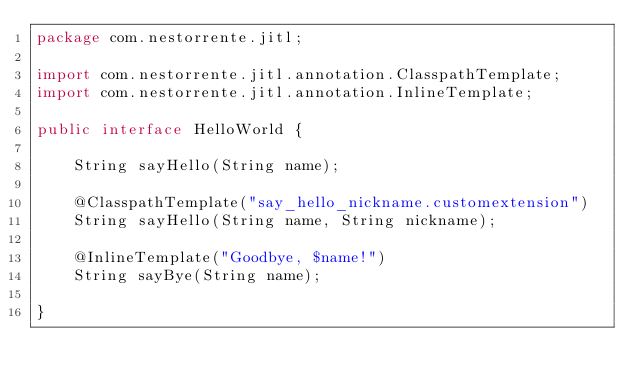Convert code to text. <code><loc_0><loc_0><loc_500><loc_500><_Java_>package com.nestorrente.jitl;

import com.nestorrente.jitl.annotation.ClasspathTemplate;
import com.nestorrente.jitl.annotation.InlineTemplate;

public interface HelloWorld {

	String sayHello(String name);

	@ClasspathTemplate("say_hello_nickname.customextension")
	String sayHello(String name, String nickname);

	@InlineTemplate("Goodbye, $name!")
	String sayBye(String name);

}
</code> 